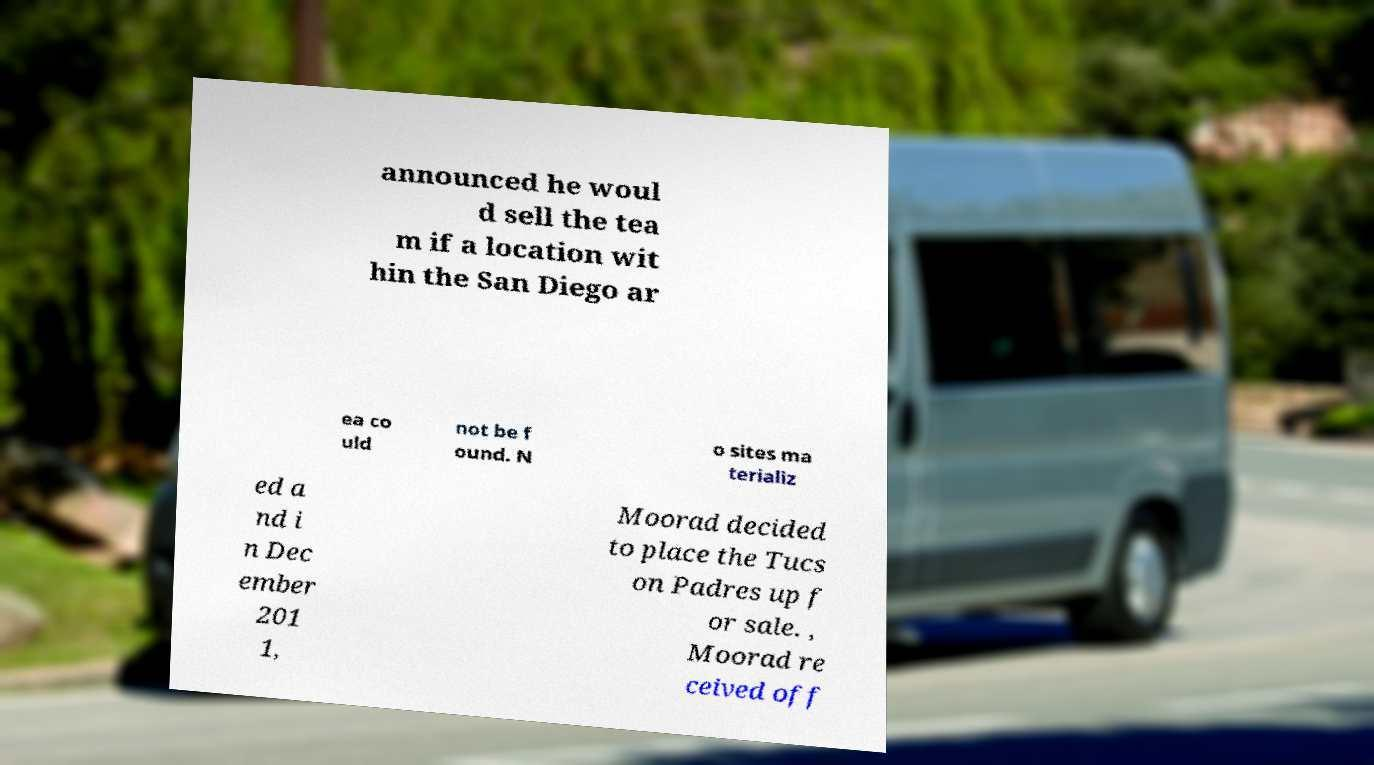Please identify and transcribe the text found in this image. announced he woul d sell the tea m if a location wit hin the San Diego ar ea co uld not be f ound. N o sites ma terializ ed a nd i n Dec ember 201 1, Moorad decided to place the Tucs on Padres up f or sale. , Moorad re ceived off 